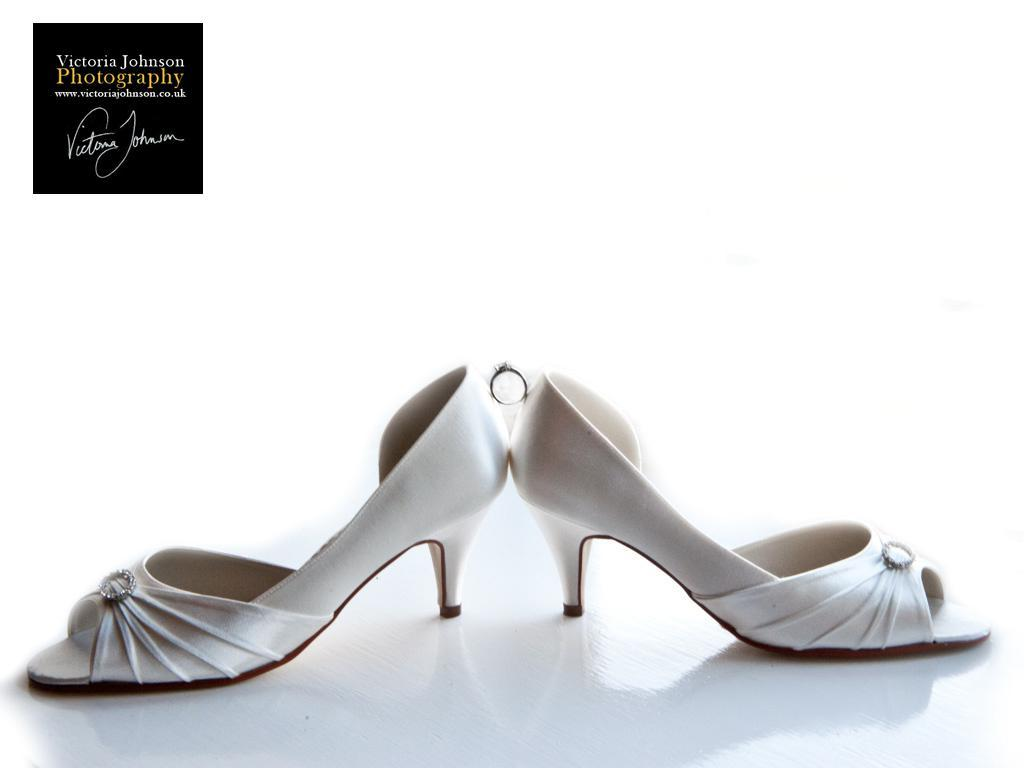What type of footwear is featured in the image? There are heels in the image. What else can be seen at the top of the image? There is text at the top of the image. What type of trees can be seen swaying in the wind in the image? There are no trees or wind present in the image; it only features heels and text. 